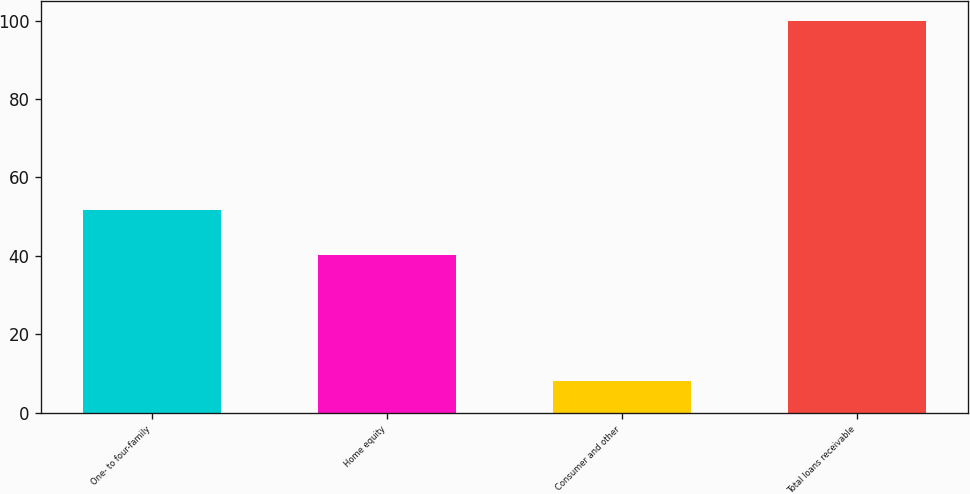<chart> <loc_0><loc_0><loc_500><loc_500><bar_chart><fcel>One- to four-family<fcel>Home equity<fcel>Consumer and other<fcel>Total loans receivable<nl><fcel>51.8<fcel>40.2<fcel>8<fcel>100<nl></chart> 